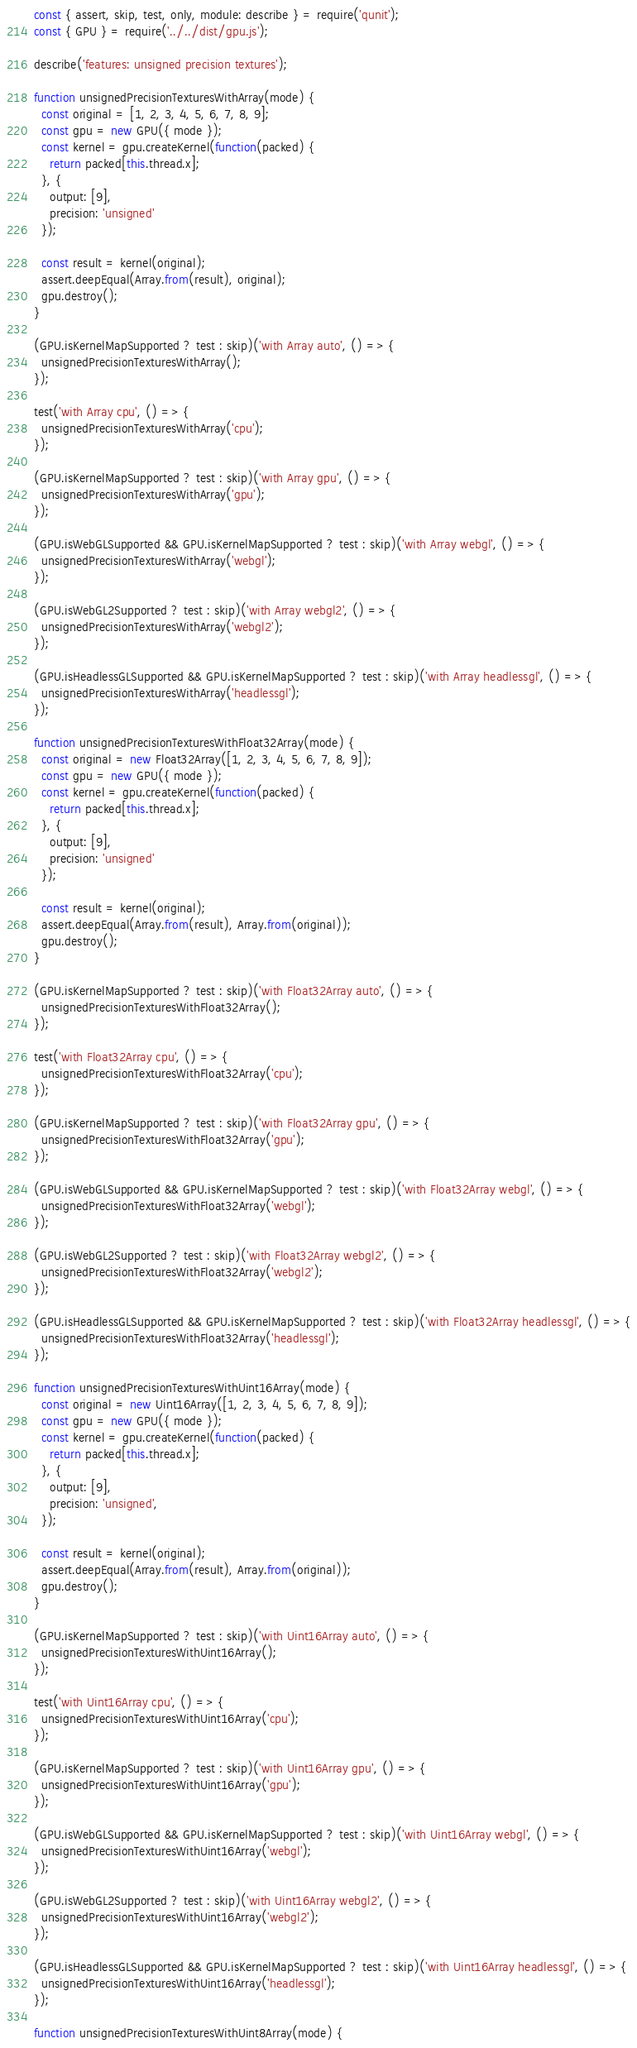Convert code to text. <code><loc_0><loc_0><loc_500><loc_500><_JavaScript_>const { assert, skip, test, only, module: describe } = require('qunit');
const { GPU } = require('../../dist/gpu.js');

describe('features: unsigned precision textures');

function unsignedPrecisionTexturesWithArray(mode) {
  const original = [1, 2, 3, 4, 5, 6, 7, 8, 9];
  const gpu = new GPU({ mode });
  const kernel = gpu.createKernel(function(packed) {
    return packed[this.thread.x];
  }, {
    output: [9],
    precision: 'unsigned'
  });

  const result = kernel(original);
  assert.deepEqual(Array.from(result), original);
  gpu.destroy();
}

(GPU.isKernelMapSupported ? test : skip)('with Array auto', () => {
  unsignedPrecisionTexturesWithArray();
});

test('with Array cpu', () => {
  unsignedPrecisionTexturesWithArray('cpu');
});

(GPU.isKernelMapSupported ? test : skip)('with Array gpu', () => {
  unsignedPrecisionTexturesWithArray('gpu');
});

(GPU.isWebGLSupported && GPU.isKernelMapSupported ? test : skip)('with Array webgl', () => {
  unsignedPrecisionTexturesWithArray('webgl');
});

(GPU.isWebGL2Supported ? test : skip)('with Array webgl2', () => {
  unsignedPrecisionTexturesWithArray('webgl2');
});

(GPU.isHeadlessGLSupported && GPU.isKernelMapSupported ? test : skip)('with Array headlessgl', () => {
  unsignedPrecisionTexturesWithArray('headlessgl');
});

function unsignedPrecisionTexturesWithFloat32Array(mode) {
  const original = new Float32Array([1, 2, 3, 4, 5, 6, 7, 8, 9]);
  const gpu = new GPU({ mode });
  const kernel = gpu.createKernel(function(packed) {
    return packed[this.thread.x];
  }, {
    output: [9],
    precision: 'unsigned'
  });

  const result = kernel(original);
  assert.deepEqual(Array.from(result), Array.from(original));
  gpu.destroy();
}

(GPU.isKernelMapSupported ? test : skip)('with Float32Array auto', () => {
  unsignedPrecisionTexturesWithFloat32Array();
});

test('with Float32Array cpu', () => {
  unsignedPrecisionTexturesWithFloat32Array('cpu');
});

(GPU.isKernelMapSupported ? test : skip)('with Float32Array gpu', () => {
  unsignedPrecisionTexturesWithFloat32Array('gpu');
});

(GPU.isWebGLSupported && GPU.isKernelMapSupported ? test : skip)('with Float32Array webgl', () => {
  unsignedPrecisionTexturesWithFloat32Array('webgl');
});

(GPU.isWebGL2Supported ? test : skip)('with Float32Array webgl2', () => {
  unsignedPrecisionTexturesWithFloat32Array('webgl2');
});

(GPU.isHeadlessGLSupported && GPU.isKernelMapSupported ? test : skip)('with Float32Array headlessgl', () => {
  unsignedPrecisionTexturesWithFloat32Array('headlessgl');
});

function unsignedPrecisionTexturesWithUint16Array(mode) {
  const original = new Uint16Array([1, 2, 3, 4, 5, 6, 7, 8, 9]);
  const gpu = new GPU({ mode });
  const kernel = gpu.createKernel(function(packed) {
    return packed[this.thread.x];
  }, {
    output: [9],
    precision: 'unsigned',
  });

  const result = kernel(original);
  assert.deepEqual(Array.from(result), Array.from(original));
  gpu.destroy();
}

(GPU.isKernelMapSupported ? test : skip)('with Uint16Array auto', () => {
  unsignedPrecisionTexturesWithUint16Array();
});

test('with Uint16Array cpu', () => {
  unsignedPrecisionTexturesWithUint16Array('cpu');
});

(GPU.isKernelMapSupported ? test : skip)('with Uint16Array gpu', () => {
  unsignedPrecisionTexturesWithUint16Array('gpu');
});

(GPU.isWebGLSupported && GPU.isKernelMapSupported ? test : skip)('with Uint16Array webgl', () => {
  unsignedPrecisionTexturesWithUint16Array('webgl');
});

(GPU.isWebGL2Supported ? test : skip)('with Uint16Array webgl2', () => {
  unsignedPrecisionTexturesWithUint16Array('webgl2');
});

(GPU.isHeadlessGLSupported && GPU.isKernelMapSupported ? test : skip)('with Uint16Array headlessgl', () => {
  unsignedPrecisionTexturesWithUint16Array('headlessgl');
});

function unsignedPrecisionTexturesWithUint8Array(mode) {</code> 